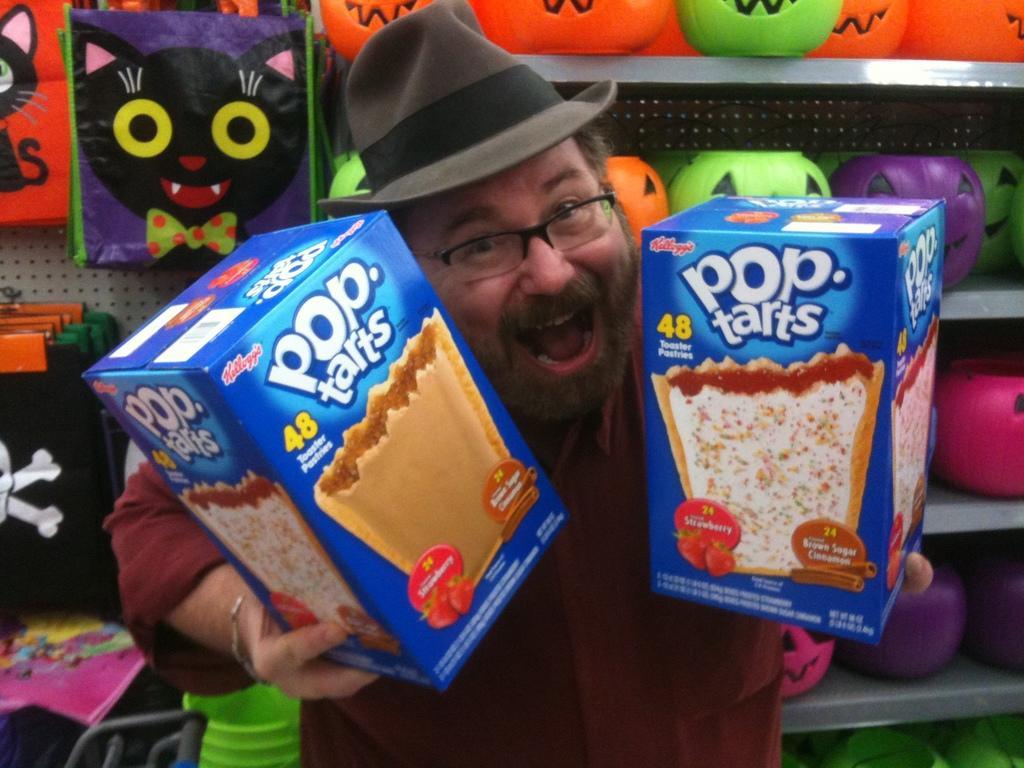Can you describe this image briefly? In the image there is a man he is holding some snacks boxes with his hand and behind the man there are some toys and bags. 